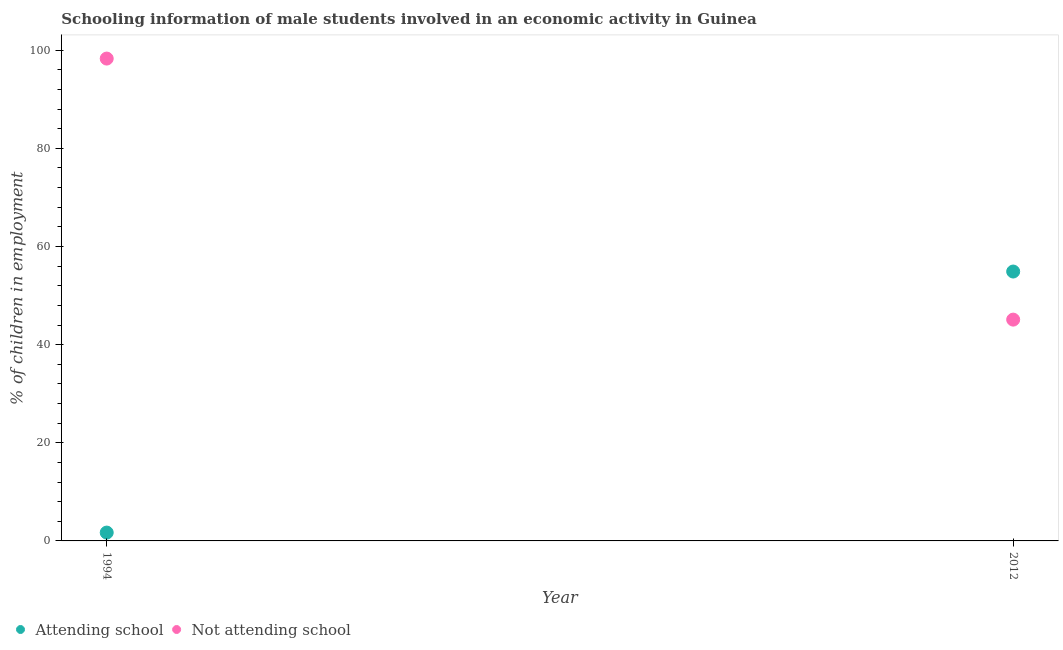Is the number of dotlines equal to the number of legend labels?
Keep it short and to the point. Yes. What is the percentage of employed males who are not attending school in 1994?
Your response must be concise. 98.3. Across all years, what is the maximum percentage of employed males who are attending school?
Your answer should be very brief. 54.9. Across all years, what is the minimum percentage of employed males who are attending school?
Your answer should be very brief. 1.7. In which year was the percentage of employed males who are attending school maximum?
Provide a short and direct response. 2012. In which year was the percentage of employed males who are attending school minimum?
Provide a succinct answer. 1994. What is the total percentage of employed males who are attending school in the graph?
Give a very brief answer. 56.6. What is the difference between the percentage of employed males who are attending school in 1994 and that in 2012?
Keep it short and to the point. -53.2. What is the difference between the percentage of employed males who are attending school in 1994 and the percentage of employed males who are not attending school in 2012?
Offer a terse response. -43.4. What is the average percentage of employed males who are attending school per year?
Your response must be concise. 28.3. In the year 1994, what is the difference between the percentage of employed males who are not attending school and percentage of employed males who are attending school?
Give a very brief answer. 96.6. In how many years, is the percentage of employed males who are not attending school greater than 64 %?
Your answer should be compact. 1. What is the ratio of the percentage of employed males who are not attending school in 1994 to that in 2012?
Offer a terse response. 2.18. Is the percentage of employed males who are not attending school in 1994 less than that in 2012?
Your response must be concise. No. Does the percentage of employed males who are not attending school monotonically increase over the years?
Your answer should be very brief. No. Is the percentage of employed males who are attending school strictly greater than the percentage of employed males who are not attending school over the years?
Ensure brevity in your answer.  No. Is the percentage of employed males who are not attending school strictly less than the percentage of employed males who are attending school over the years?
Provide a succinct answer. No. How many dotlines are there?
Give a very brief answer. 2. What is the difference between two consecutive major ticks on the Y-axis?
Your answer should be very brief. 20. Are the values on the major ticks of Y-axis written in scientific E-notation?
Offer a terse response. No. Does the graph contain any zero values?
Ensure brevity in your answer.  No. Does the graph contain grids?
Keep it short and to the point. No. Where does the legend appear in the graph?
Give a very brief answer. Bottom left. How many legend labels are there?
Your answer should be very brief. 2. How are the legend labels stacked?
Make the answer very short. Horizontal. What is the title of the graph?
Provide a short and direct response. Schooling information of male students involved in an economic activity in Guinea. Does "Female" appear as one of the legend labels in the graph?
Ensure brevity in your answer.  No. What is the label or title of the X-axis?
Offer a very short reply. Year. What is the label or title of the Y-axis?
Provide a short and direct response. % of children in employment. What is the % of children in employment of Attending school in 1994?
Provide a short and direct response. 1.7. What is the % of children in employment in Not attending school in 1994?
Offer a very short reply. 98.3. What is the % of children in employment in Attending school in 2012?
Provide a succinct answer. 54.9. What is the % of children in employment in Not attending school in 2012?
Provide a succinct answer. 45.1. Across all years, what is the maximum % of children in employment of Attending school?
Your answer should be very brief. 54.9. Across all years, what is the maximum % of children in employment in Not attending school?
Offer a very short reply. 98.3. Across all years, what is the minimum % of children in employment of Not attending school?
Your response must be concise. 45.1. What is the total % of children in employment of Attending school in the graph?
Make the answer very short. 56.6. What is the total % of children in employment of Not attending school in the graph?
Make the answer very short. 143.4. What is the difference between the % of children in employment of Attending school in 1994 and that in 2012?
Offer a terse response. -53.2. What is the difference between the % of children in employment of Not attending school in 1994 and that in 2012?
Provide a succinct answer. 53.2. What is the difference between the % of children in employment in Attending school in 1994 and the % of children in employment in Not attending school in 2012?
Make the answer very short. -43.4. What is the average % of children in employment of Attending school per year?
Offer a terse response. 28.3. What is the average % of children in employment in Not attending school per year?
Your answer should be compact. 71.7. In the year 1994, what is the difference between the % of children in employment of Attending school and % of children in employment of Not attending school?
Your answer should be very brief. -96.6. In the year 2012, what is the difference between the % of children in employment in Attending school and % of children in employment in Not attending school?
Your answer should be very brief. 9.8. What is the ratio of the % of children in employment of Attending school in 1994 to that in 2012?
Ensure brevity in your answer.  0.03. What is the ratio of the % of children in employment of Not attending school in 1994 to that in 2012?
Make the answer very short. 2.18. What is the difference between the highest and the second highest % of children in employment in Attending school?
Provide a short and direct response. 53.2. What is the difference between the highest and the second highest % of children in employment in Not attending school?
Give a very brief answer. 53.2. What is the difference between the highest and the lowest % of children in employment of Attending school?
Your answer should be very brief. 53.2. What is the difference between the highest and the lowest % of children in employment of Not attending school?
Provide a short and direct response. 53.2. 